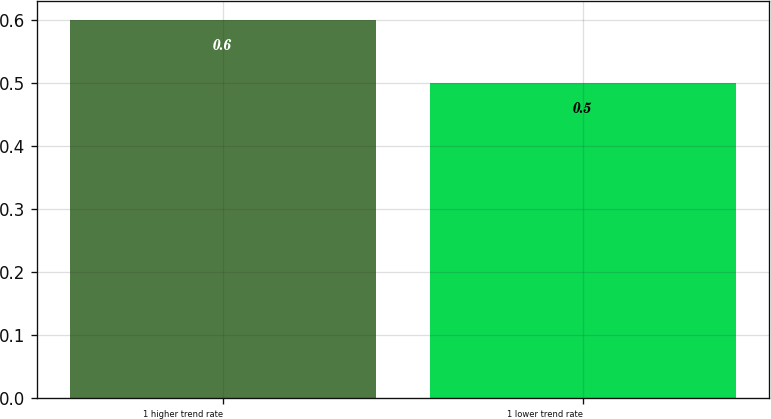Convert chart. <chart><loc_0><loc_0><loc_500><loc_500><bar_chart><fcel>1 higher trend rate<fcel>1 lower trend rate<nl><fcel>0.6<fcel>0.5<nl></chart> 